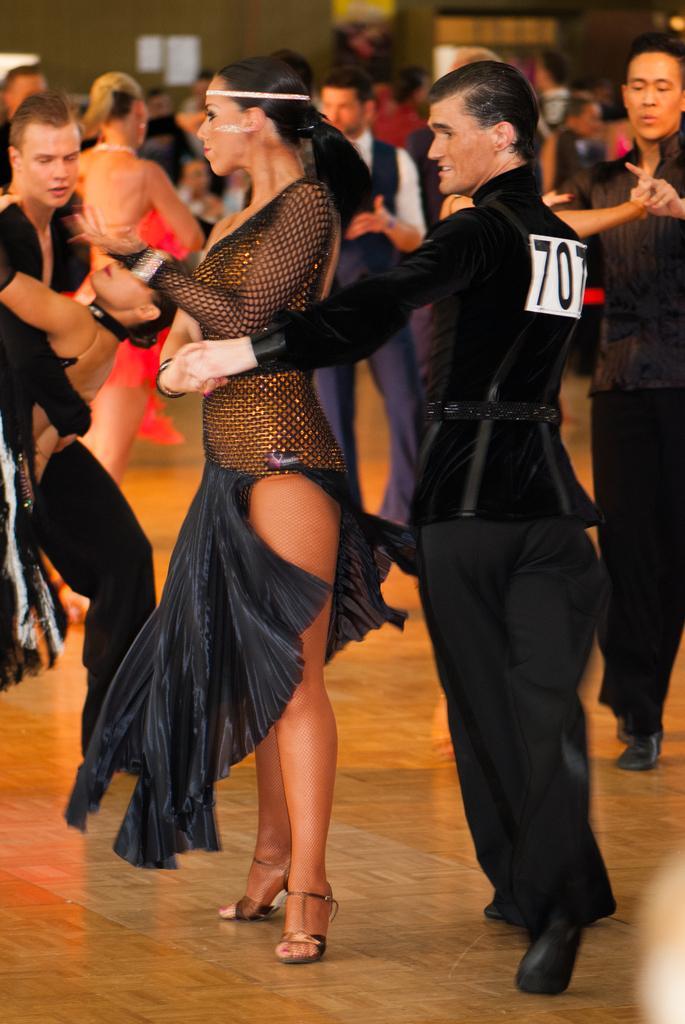How would you summarize this image in a sentence or two? In the image I can see people are standing. 